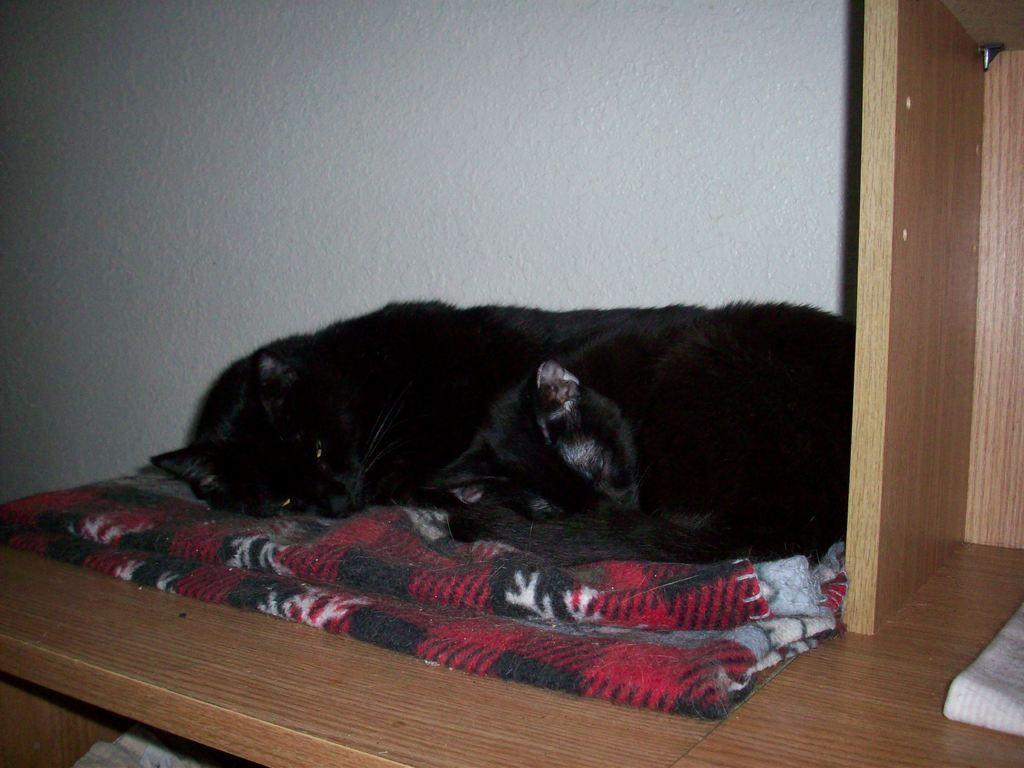In one or two sentences, can you explain what this image depicts? In this image I can see the cat which is in black color. It is on the red, white and black color cloth. In the back I can see the white wall. It is on the wooden surface. 